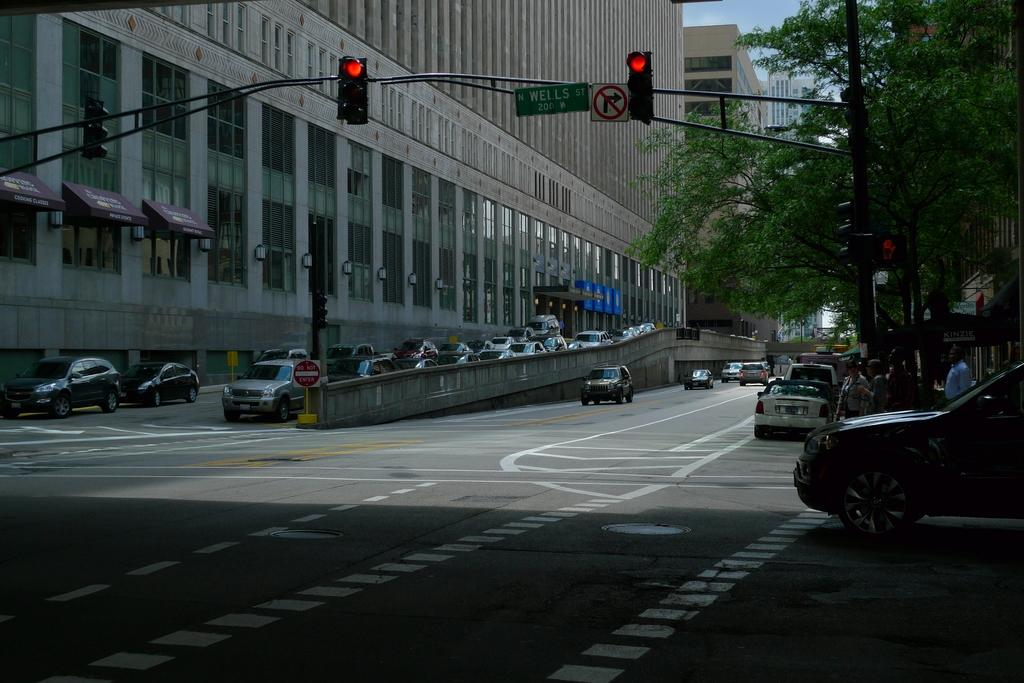<image>
Render a clear and concise summary of the photo. a red light with the word wells near the light 